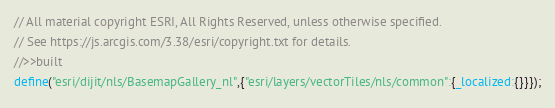<code> <loc_0><loc_0><loc_500><loc_500><_JavaScript_>// All material copyright ESRI, All Rights Reserved, unless otherwise specified.
// See https://js.arcgis.com/3.38/esri/copyright.txt for details.
//>>built
define("esri/dijit/nls/BasemapGallery_nl",{"esri/layers/vectorTiles/nls/common":{_localized:{}}});</code> 